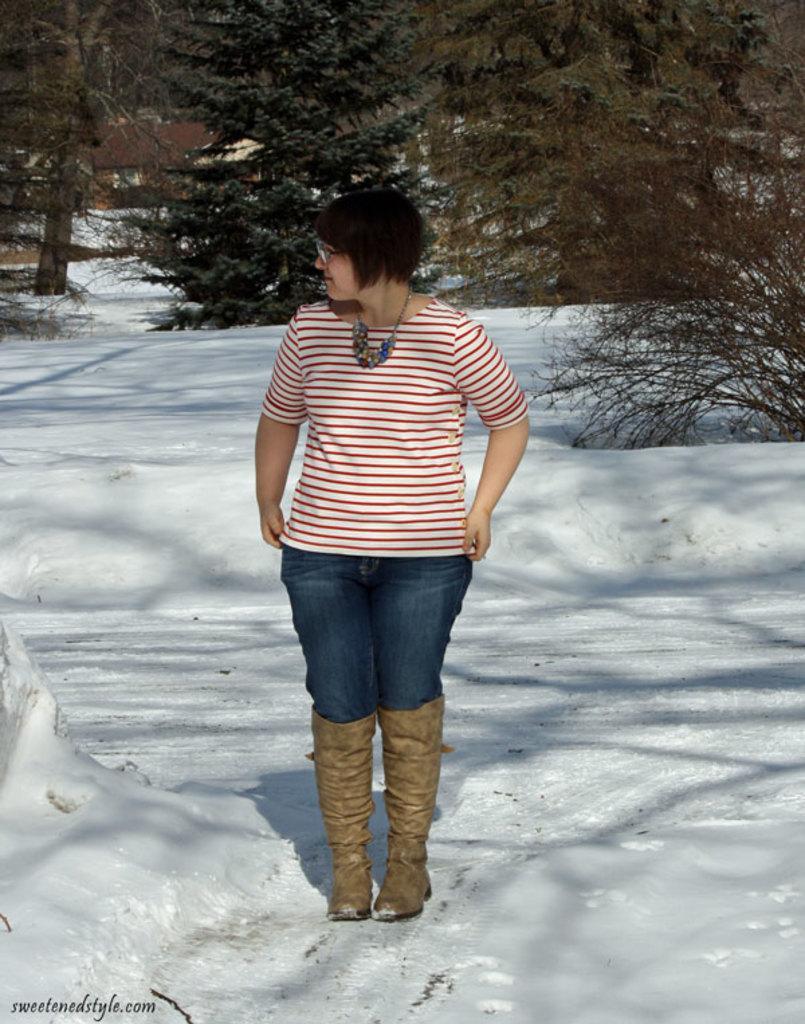Can you describe this image briefly? In this image we can see a woman standing on the ground. We can also see the snow, a group of trees and a house. 